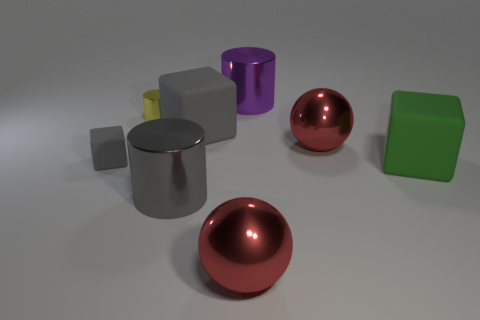Subtract all small yellow cylinders. How many cylinders are left? 2 Subtract all gray cylinders. How many cylinders are left? 2 Add 1 metallic balls. How many objects exist? 9 Subtract 1 cubes. How many cubes are left? 2 Subtract all green blocks. Subtract all green cylinders. How many blocks are left? 2 Subtract all brown spheres. How many gray cylinders are left? 1 Subtract all tiny cyan shiny objects. Subtract all purple metallic things. How many objects are left? 7 Add 7 large shiny cylinders. How many large shiny cylinders are left? 9 Add 1 tiny gray matte cylinders. How many tiny gray matte cylinders exist? 1 Subtract 0 purple blocks. How many objects are left? 8 